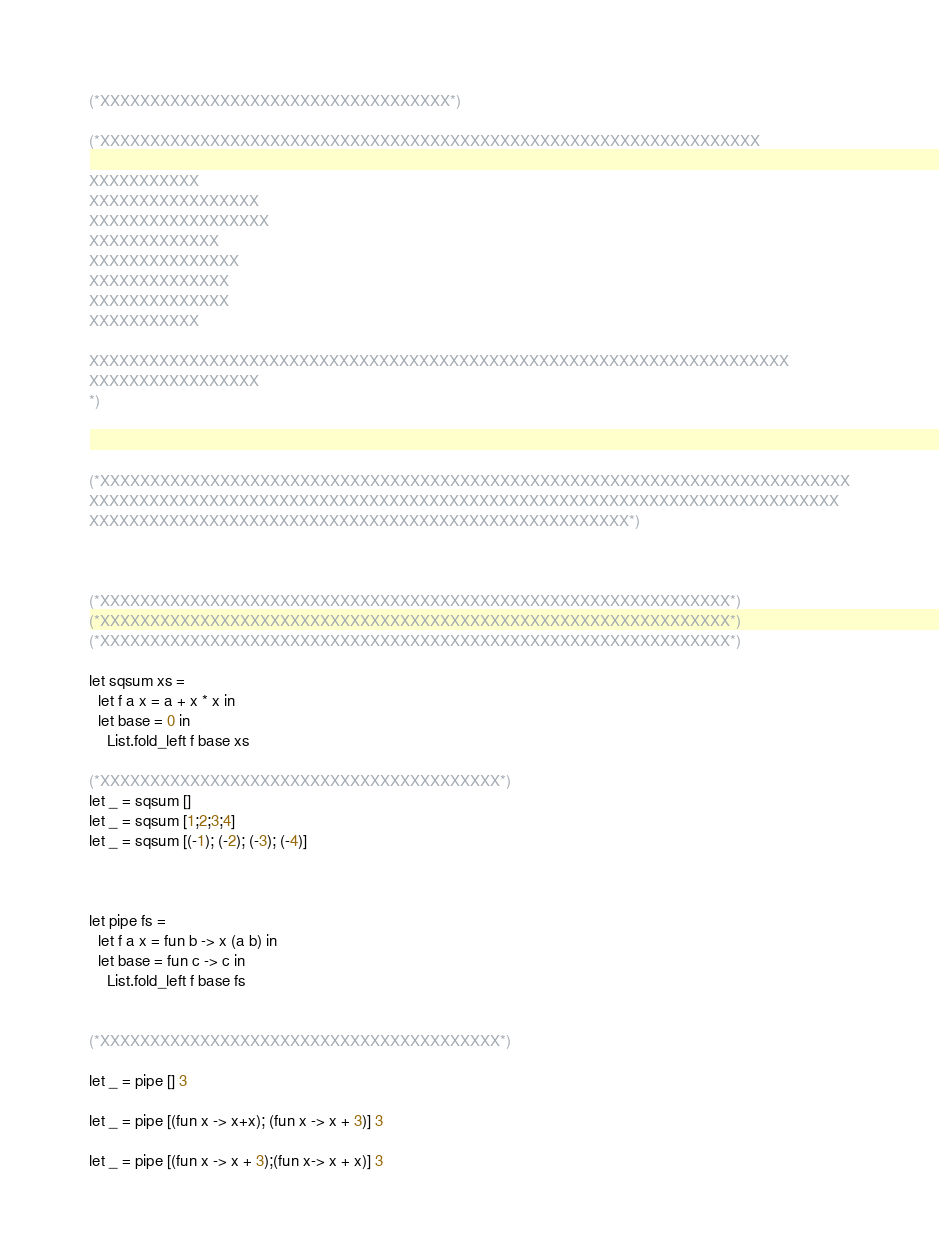Convert code to text. <code><loc_0><loc_0><loc_500><loc_500><_OCaml_>(*XXXXXXXXXXXXXXXXXXXXXXXXXXXXXXXXXXX*)

(*XXXXXXXXXXXXXXXXXXXXXXXXXXXXXXXXXXXXXXXXXXXXXXXXXXXXXXXXXXXXXXXXXX

XXXXXXXXXXX
XXXXXXXXXXXXXXXXX
XXXXXXXXXXXXXXXXXX
XXXXXXXXXXXXX
XXXXXXXXXXXXXXX
XXXXXXXXXXXXXX
XXXXXXXXXXXXXX
XXXXXXXXXXX

XXXXXXXXXXXXXXXXXXXXXXXXXXXXXXXXXXXXXXXXXXXXXXXXXXXXXXXXXXXXXXXXXXXXXX
XXXXXXXXXXXXXXXXX
*)



(*XXXXXXXXXXXXXXXXXXXXXXXXXXXXXXXXXXXXXXXXXXXXXXXXXXXXXXXXXXXXXXXXXXXXXXXXXXX
XXXXXXXXXXXXXXXXXXXXXXXXXXXXXXXXXXXXXXXXXXXXXXXXXXXXXXXXXXXXXXXXXXXXXXXXXXX
XXXXXXXXXXXXXXXXXXXXXXXXXXXXXXXXXXXXXXXXXXXXXXXXXXXXXX*)



(*XXXXXXXXXXXXXXXXXXXXXXXXXXXXXXXXXXXXXXXXXXXXXXXXXXXXXXXXXXXXXXX*)
(*XXXXXXXXXXXXXXXXXXXXXXXXXXXXXXXXXXXXXXXXXXXXXXXXXXXXXXXXXXXXXXX*)
(*XXXXXXXXXXXXXXXXXXXXXXXXXXXXXXXXXXXXXXXXXXXXXXXXXXXXXXXXXXXXXXX*)

let sqsum xs = 
  let f a x = a + x * x in
  let base = 0 in
    List.fold_left f base xs

(*XXXXXXXXXXXXXXXXXXXXXXXXXXXXXXXXXXXXXXXX*)
let _ = sqsum []
let _ = sqsum [1;2;3;4]
let _ = sqsum [(-1); (-2); (-3); (-4)]



let pipe fs = 
  let f a x = fun b -> x (a b) in
  let base = fun c -> c in
    List.fold_left f base fs


(*XXXXXXXXXXXXXXXXXXXXXXXXXXXXXXXXXXXXXXXX*)

let _ = pipe [] 3

let _ = pipe [(fun x -> x+x); (fun x -> x + 3)] 3

let _ = pipe [(fun x -> x + 3);(fun x-> x + x)] 3



</code> 